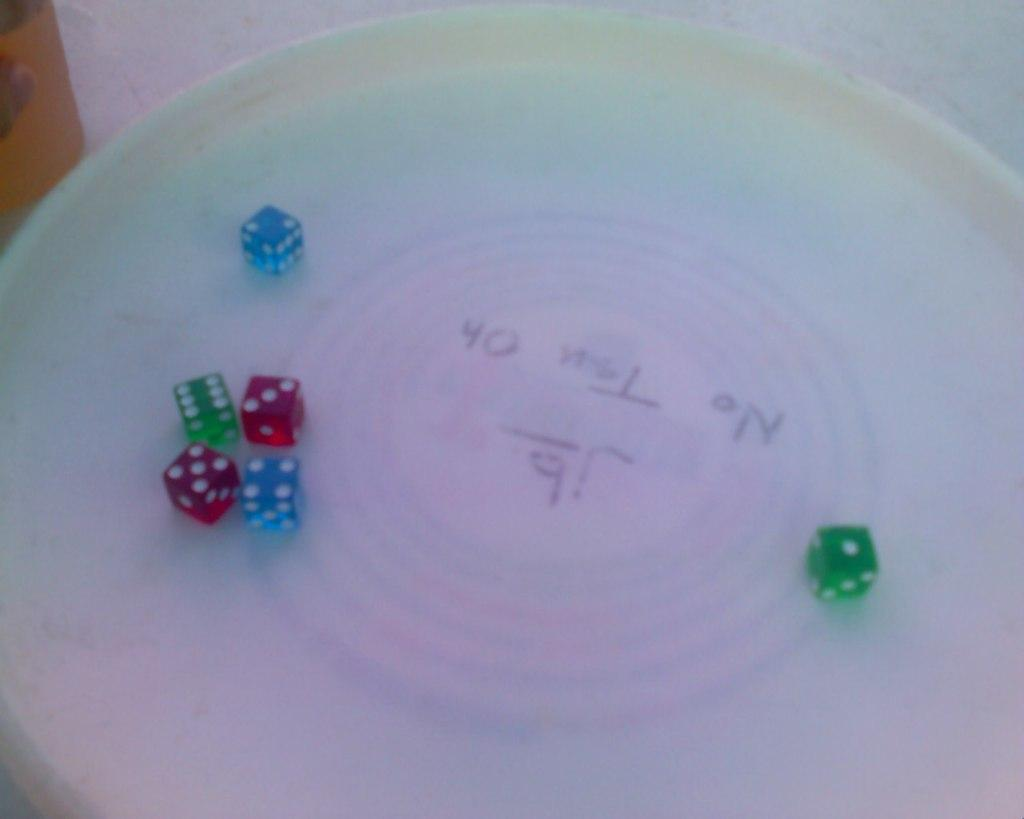What is on the plate in the image? There are six dice on the plate in the image. What colors can be seen on the dice? The dice have blue, red, and green colors. How many feet are visible on the dice in the image? There are no feet visible on the dice in the image, as dice do not have feet. 